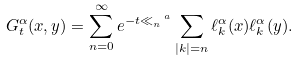Convert formula to latex. <formula><loc_0><loc_0><loc_500><loc_500>G ^ { \alpha } _ { t } ( x , y ) = \sum _ { n = 0 } ^ { \infty } e ^ { - t \ll _ { n } ^ { \ a } } \sum _ { | k | = n } \ell _ { k } ^ { \alpha } ( x ) \ell _ { k } ^ { \alpha } ( y ) .</formula> 